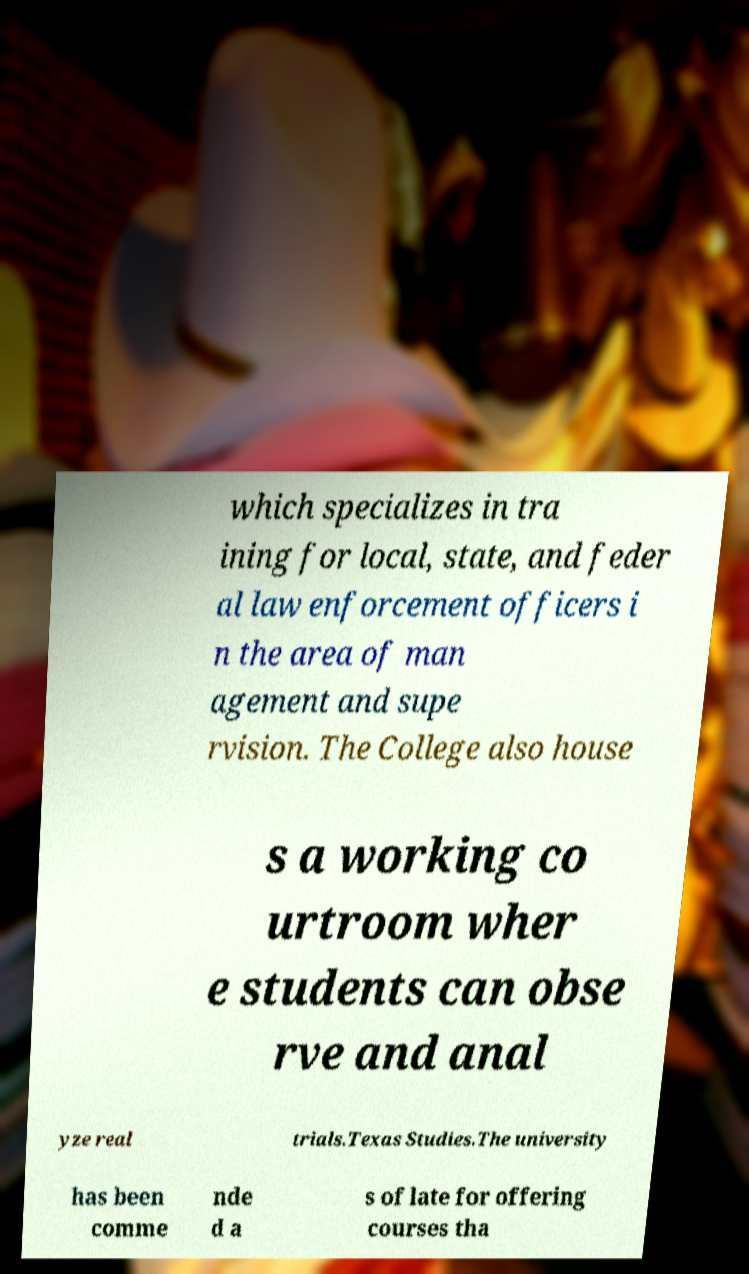Please read and relay the text visible in this image. What does it say? which specializes in tra ining for local, state, and feder al law enforcement officers i n the area of man agement and supe rvision. The College also house s a working co urtroom wher e students can obse rve and anal yze real trials.Texas Studies.The university has been comme nde d a s of late for offering courses tha 